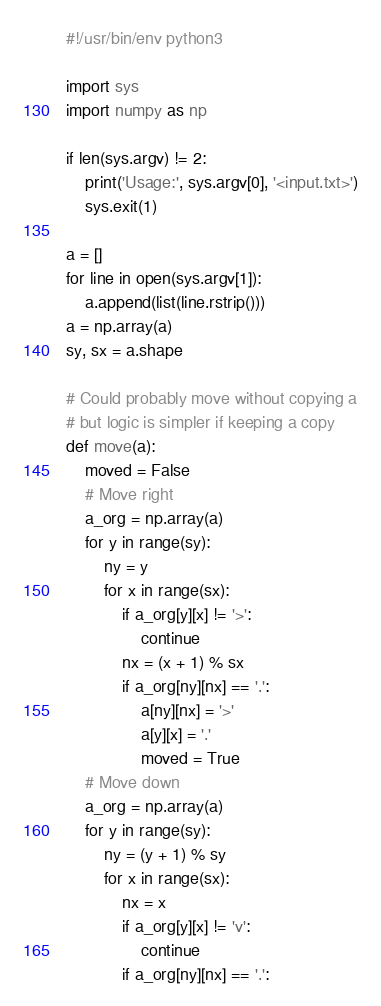Convert code to text. <code><loc_0><loc_0><loc_500><loc_500><_Python_>#!/usr/bin/env python3

import sys
import numpy as np

if len(sys.argv) != 2:
    print('Usage:', sys.argv[0], '<input.txt>')
    sys.exit(1)

a = []
for line in open(sys.argv[1]):
    a.append(list(line.rstrip()))
a = np.array(a)
sy, sx = a.shape

# Could probably move without copying a
# but logic is simpler if keeping a copy
def move(a):
    moved = False
    # Move right
    a_org = np.array(a)
    for y in range(sy):
        ny = y
        for x in range(sx):
            if a_org[y][x] != '>':
                continue
            nx = (x + 1) % sx
            if a_org[ny][nx] == '.':
                a[ny][nx] = '>'
                a[y][x] = '.'
                moved = True
    # Move down
    a_org = np.array(a)
    for y in range(sy):
        ny = (y + 1) % sy
        for x in range(sx):
            nx = x
            if a_org[y][x] != 'v':
                continue
            if a_org[ny][nx] == '.':</code> 